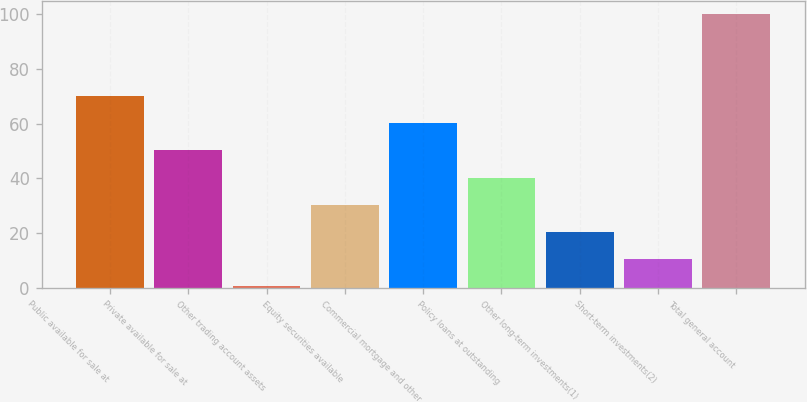Convert chart to OTSL. <chart><loc_0><loc_0><loc_500><loc_500><bar_chart><fcel>Public available for sale at<fcel>Private available for sale at<fcel>Other trading account assets<fcel>Equity securities available<fcel>Commercial mortgage and other<fcel>Policy loans at outstanding<fcel>Other long-term investments(1)<fcel>Short-term investments(2)<fcel>Total general account<nl><fcel>70.12<fcel>50.2<fcel>0.4<fcel>30.28<fcel>60.16<fcel>40.24<fcel>20.32<fcel>10.36<fcel>100<nl></chart> 